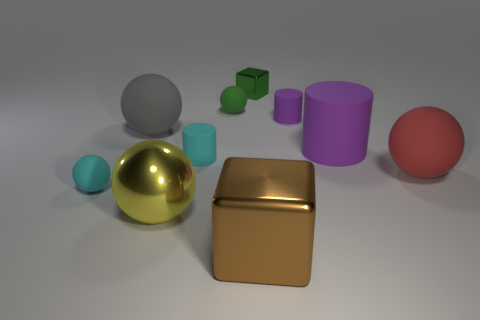What material is the big sphere that is in front of the cyan rubber thing that is in front of the matte cylinder that is left of the green ball?
Ensure brevity in your answer.  Metal. What number of small objects are yellow balls or yellow matte blocks?
Make the answer very short. 0. How many other objects are there of the same size as the green shiny object?
Your answer should be compact. 4. Does the small matte thing behind the tiny purple object have the same shape as the gray rubber object?
Provide a short and direct response. Yes. There is another big rubber object that is the same shape as the big gray object; what is its color?
Provide a short and direct response. Red. Is there anything else that has the same shape as the large gray thing?
Provide a short and direct response. Yes. Are there an equal number of shiny cubes on the left side of the shiny sphere and green shiny cylinders?
Offer a terse response. Yes. What number of balls are right of the tiny green rubber sphere and behind the large purple thing?
Your response must be concise. 0. The red thing that is the same shape as the gray object is what size?
Provide a succinct answer. Large. What number of tiny green things are the same material as the green sphere?
Offer a very short reply. 0. 